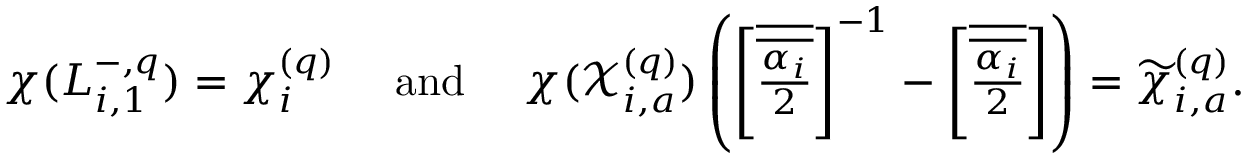Convert formula to latex. <formula><loc_0><loc_0><loc_500><loc_500>\chi ( L _ { i , 1 } ^ { - , q } ) = \chi _ { i } ^ { ( q ) } \quad a n d \quad \chi ( \mathcal { X } _ { i , a } ^ { ( q ) } ) \left ( { \left [ \overline { { \overline { { \frac { \alpha _ { i } } { 2 } } } } } \right ] ^ { - 1 } - \left [ \overline { { \overline { { \frac { \alpha _ { i } } { 2 } } } } } \right ] } \right ) = \widetilde { \chi } _ { i , a } ^ { ( q ) } .</formula> 